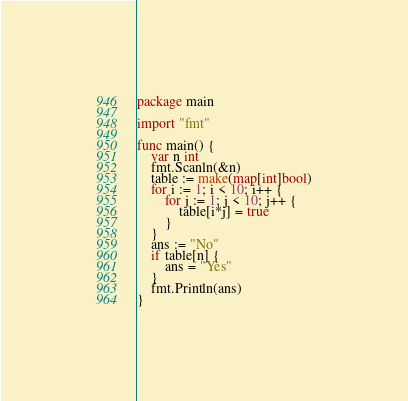<code> <loc_0><loc_0><loc_500><loc_500><_Go_>package main

import "fmt"

func main() {
	var n int
	fmt.Scanln(&n)
	table := make(map[int]bool)
	for i := 1; i < 10; i++ {
		for j := 1; j < 10; j++ {
			table[i*j] = true
		}
	}
	ans := "No"
	if table[n] {
		ans = "Yes"
	}
	fmt.Println(ans)
}</code> 